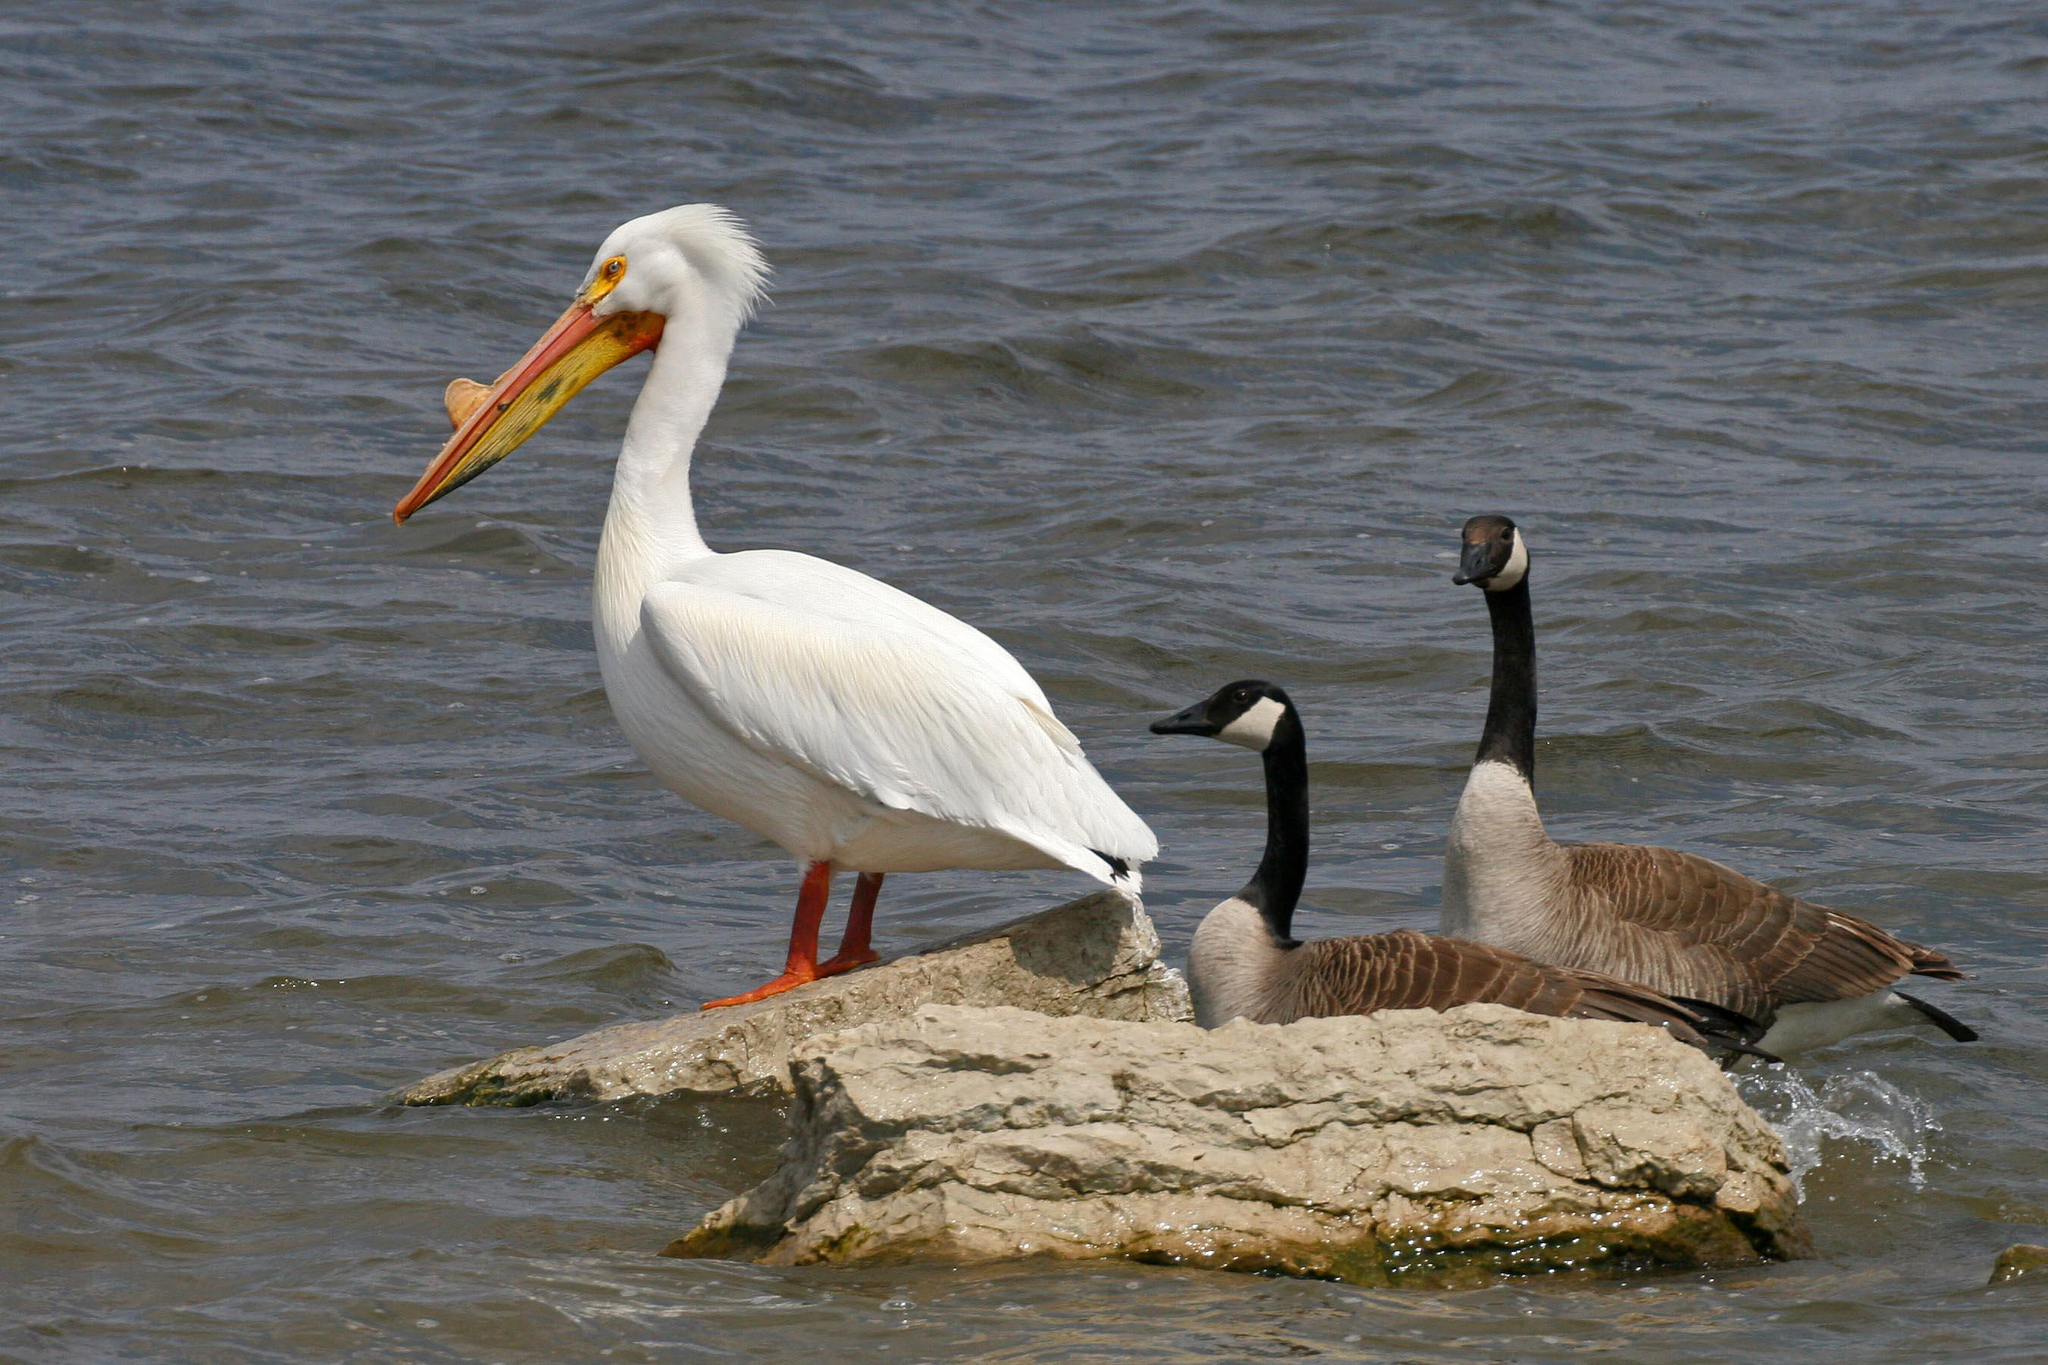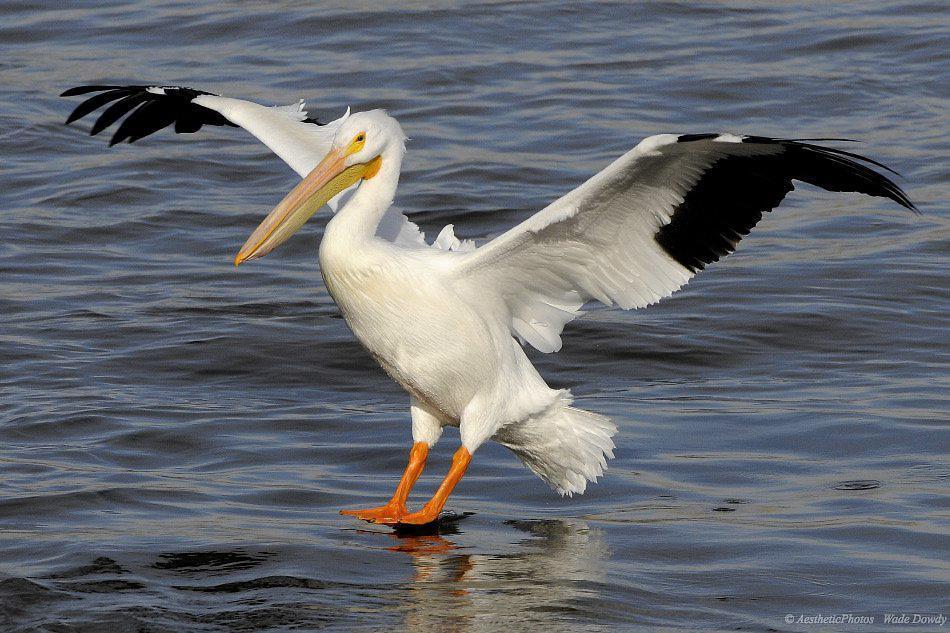The first image is the image on the left, the second image is the image on the right. For the images shown, is this caption "One image depicts more than one water bird." true? Answer yes or no. Yes. 